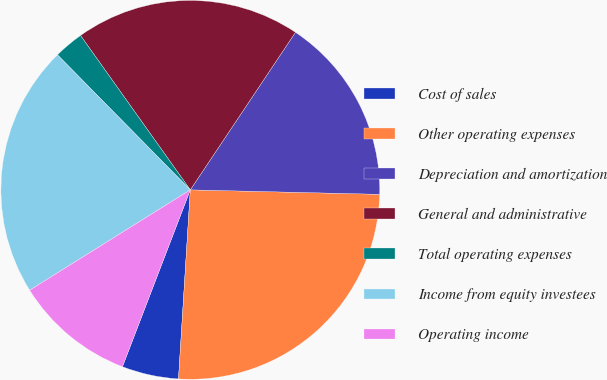Convert chart to OTSL. <chart><loc_0><loc_0><loc_500><loc_500><pie_chart><fcel>Cost of sales<fcel>Other operating expenses<fcel>Depreciation and amortization<fcel>General and administrative<fcel>Total operating expenses<fcel>Income from equity investees<fcel>Operating income<nl><fcel>4.84%<fcel>25.62%<fcel>16.01%<fcel>19.21%<fcel>2.53%<fcel>21.52%<fcel>10.28%<nl></chart> 